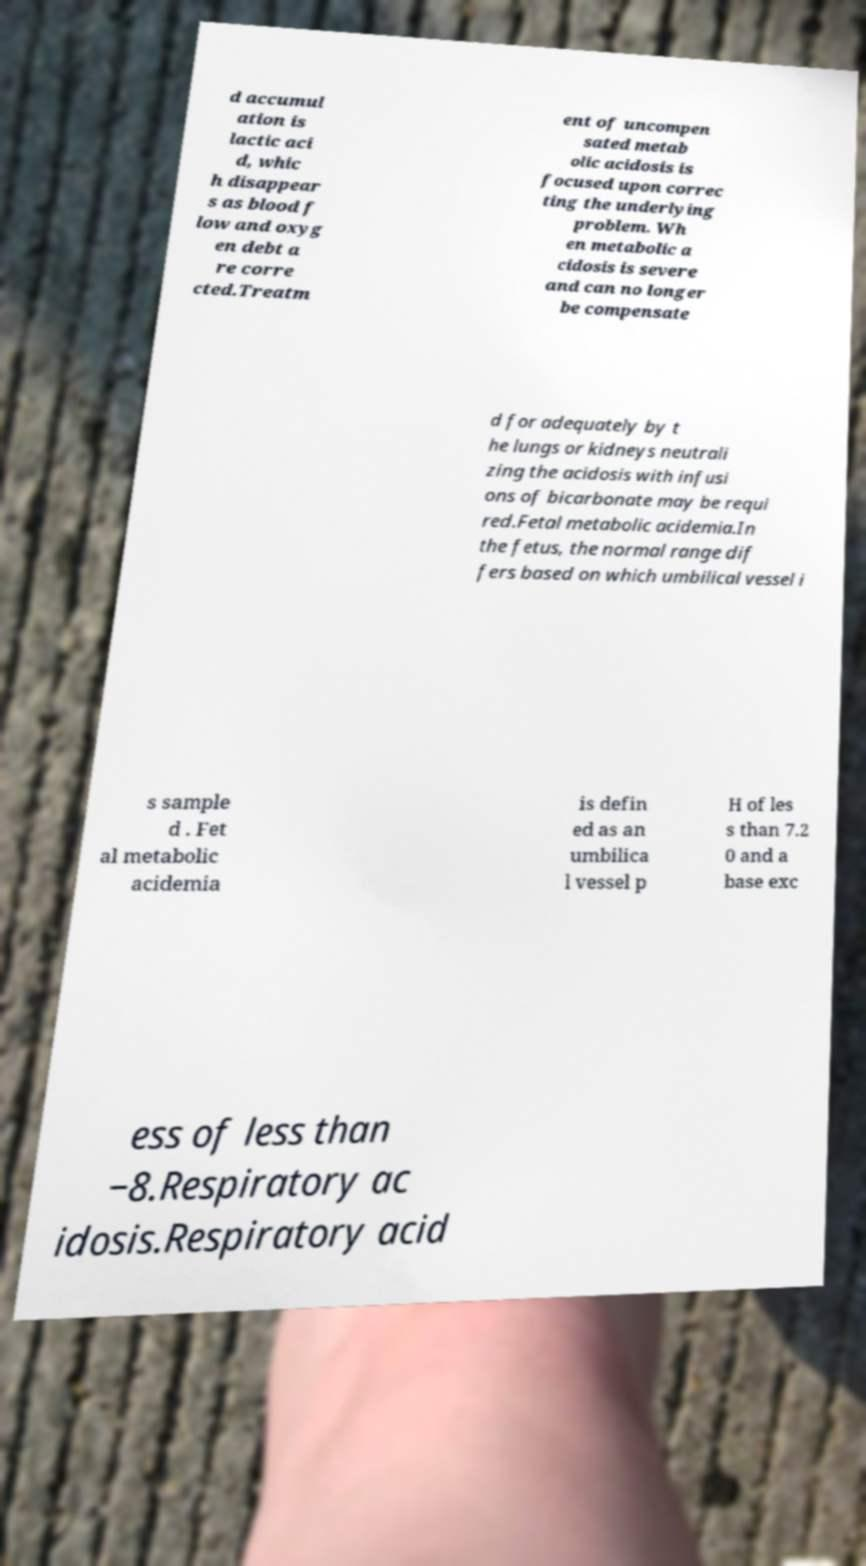There's text embedded in this image that I need extracted. Can you transcribe it verbatim? d accumul ation is lactic aci d, whic h disappear s as blood f low and oxyg en debt a re corre cted.Treatm ent of uncompen sated metab olic acidosis is focused upon correc ting the underlying problem. Wh en metabolic a cidosis is severe and can no longer be compensate d for adequately by t he lungs or kidneys neutrali zing the acidosis with infusi ons of bicarbonate may be requi red.Fetal metabolic acidemia.In the fetus, the normal range dif fers based on which umbilical vessel i s sample d . Fet al metabolic acidemia is defin ed as an umbilica l vessel p H of les s than 7.2 0 and a base exc ess of less than −8.Respiratory ac idosis.Respiratory acid 